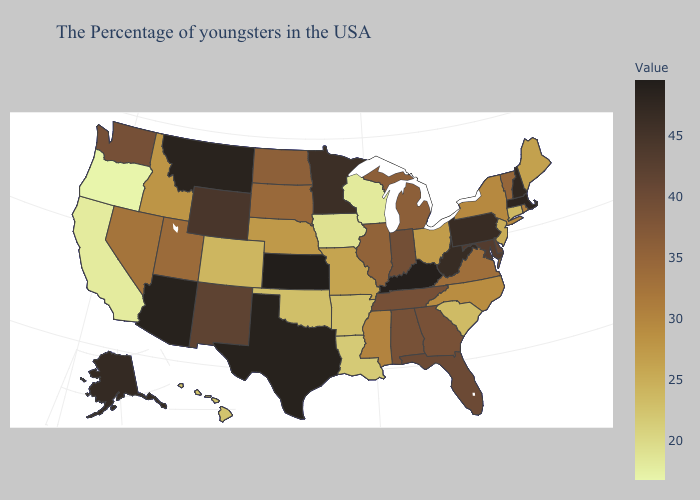Does Colorado have the lowest value in the West?
Keep it brief. No. Which states have the lowest value in the MidWest?
Short answer required. Wisconsin. Does Montana have the lowest value in the West?
Give a very brief answer. No. Among the states that border Montana , does Idaho have the lowest value?
Answer briefly. Yes. Does New Hampshire have the lowest value in the USA?
Write a very short answer. No. 